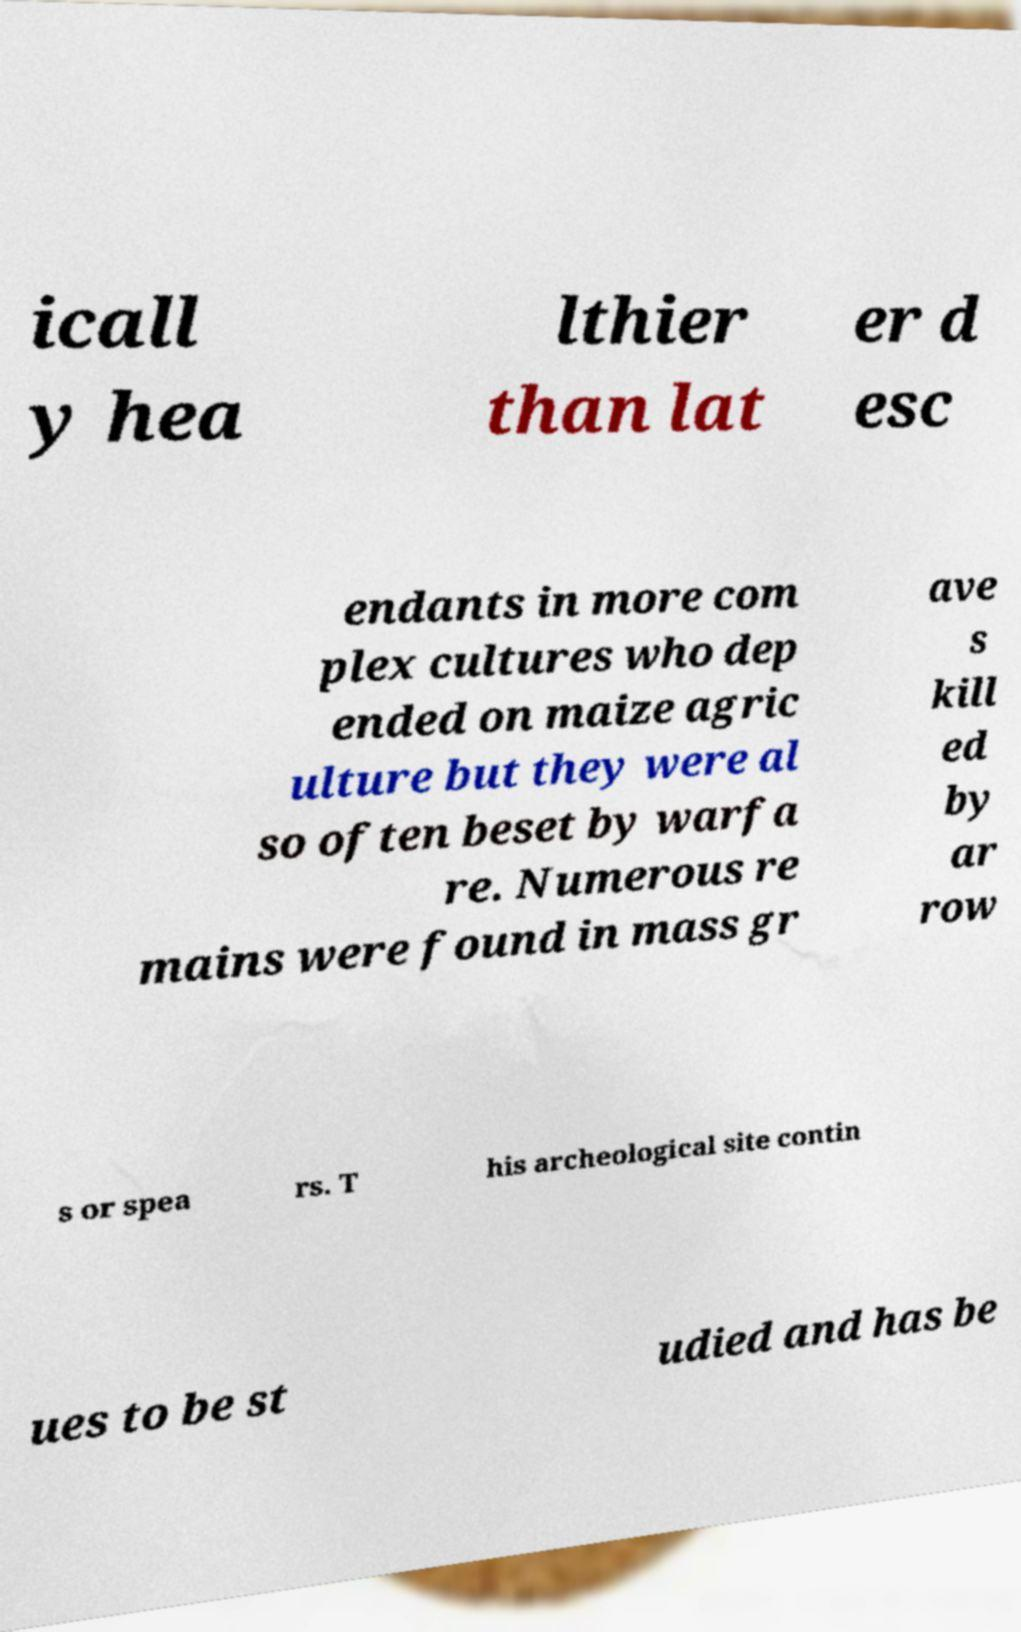I need the written content from this picture converted into text. Can you do that? icall y hea lthier than lat er d esc endants in more com plex cultures who dep ended on maize agric ulture but they were al so often beset by warfa re. Numerous re mains were found in mass gr ave s kill ed by ar row s or spea rs. T his archeological site contin ues to be st udied and has be 